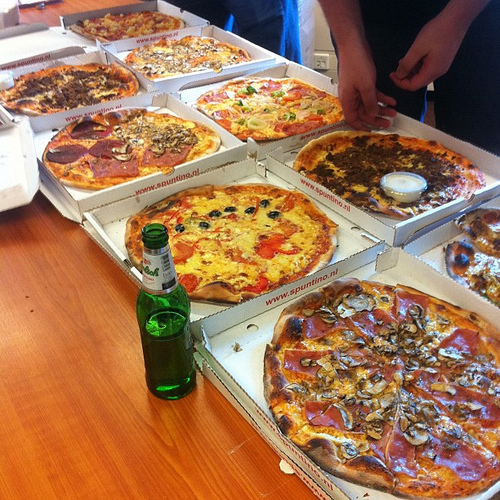What is the food to the left of the sausage on the right? The food to the left of the sausage on the right is mushrooms. 